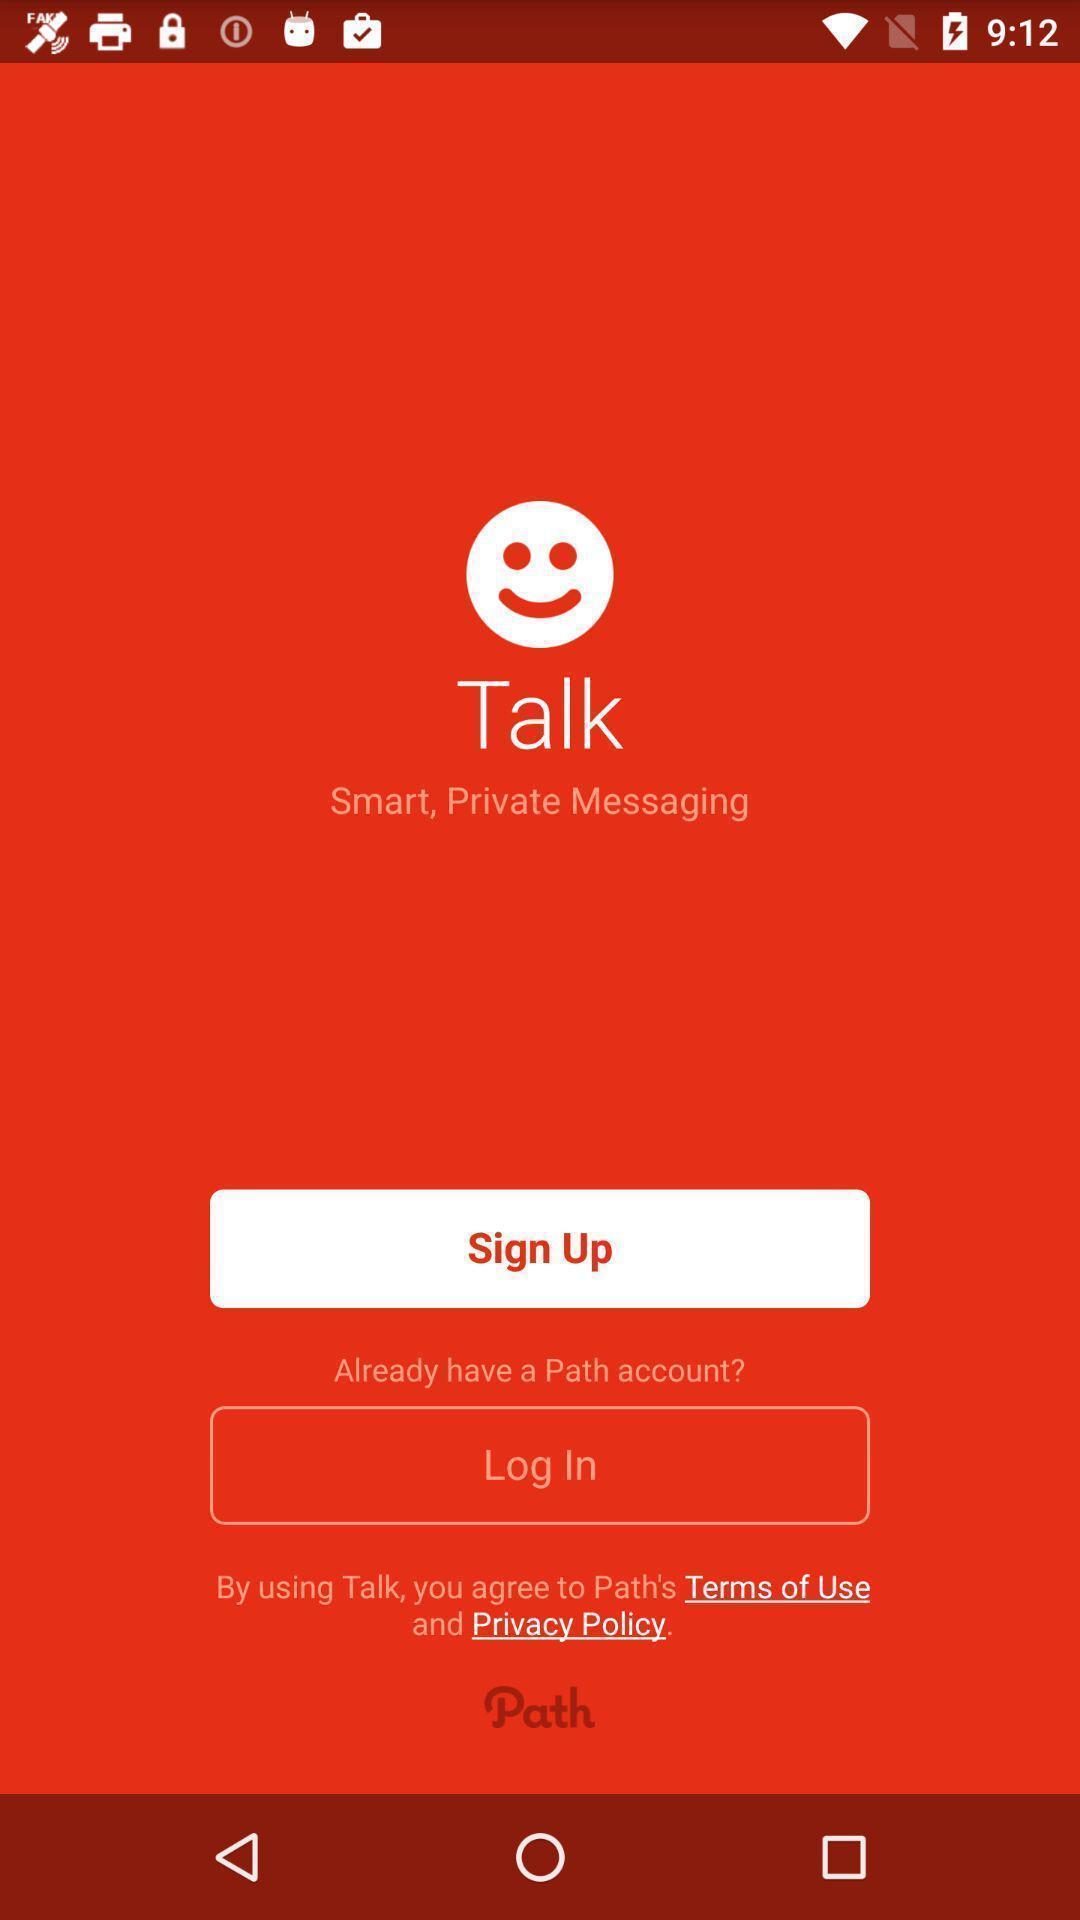Tell me what you see in this picture. Welcome page with options in a messaging app. 